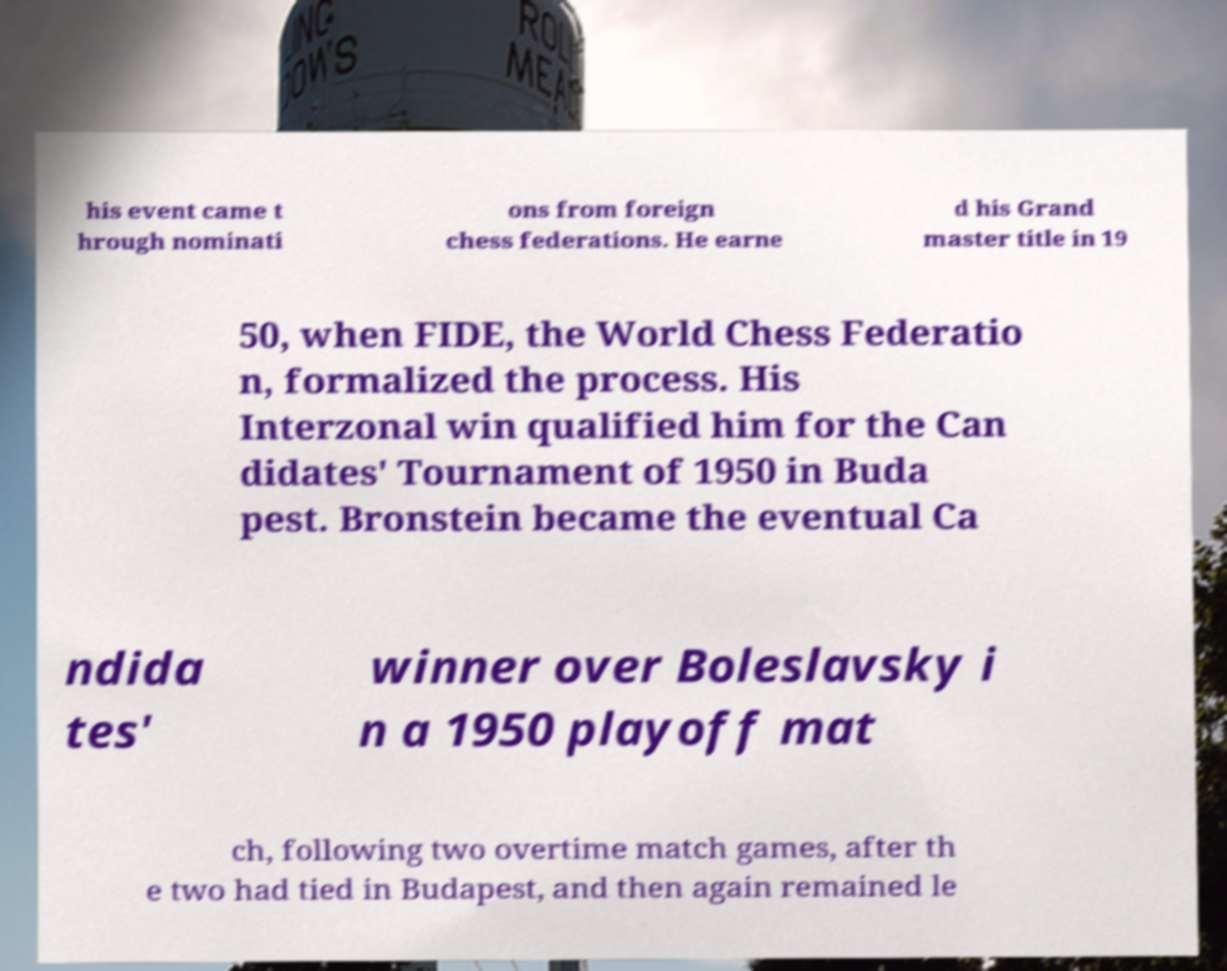What messages or text are displayed in this image? I need them in a readable, typed format. his event came t hrough nominati ons from foreign chess federations. He earne d his Grand master title in 19 50, when FIDE, the World Chess Federatio n, formalized the process. His Interzonal win qualified him for the Can didates' Tournament of 1950 in Buda pest. Bronstein became the eventual Ca ndida tes' winner over Boleslavsky i n a 1950 playoff mat ch, following two overtime match games, after th e two had tied in Budapest, and then again remained le 